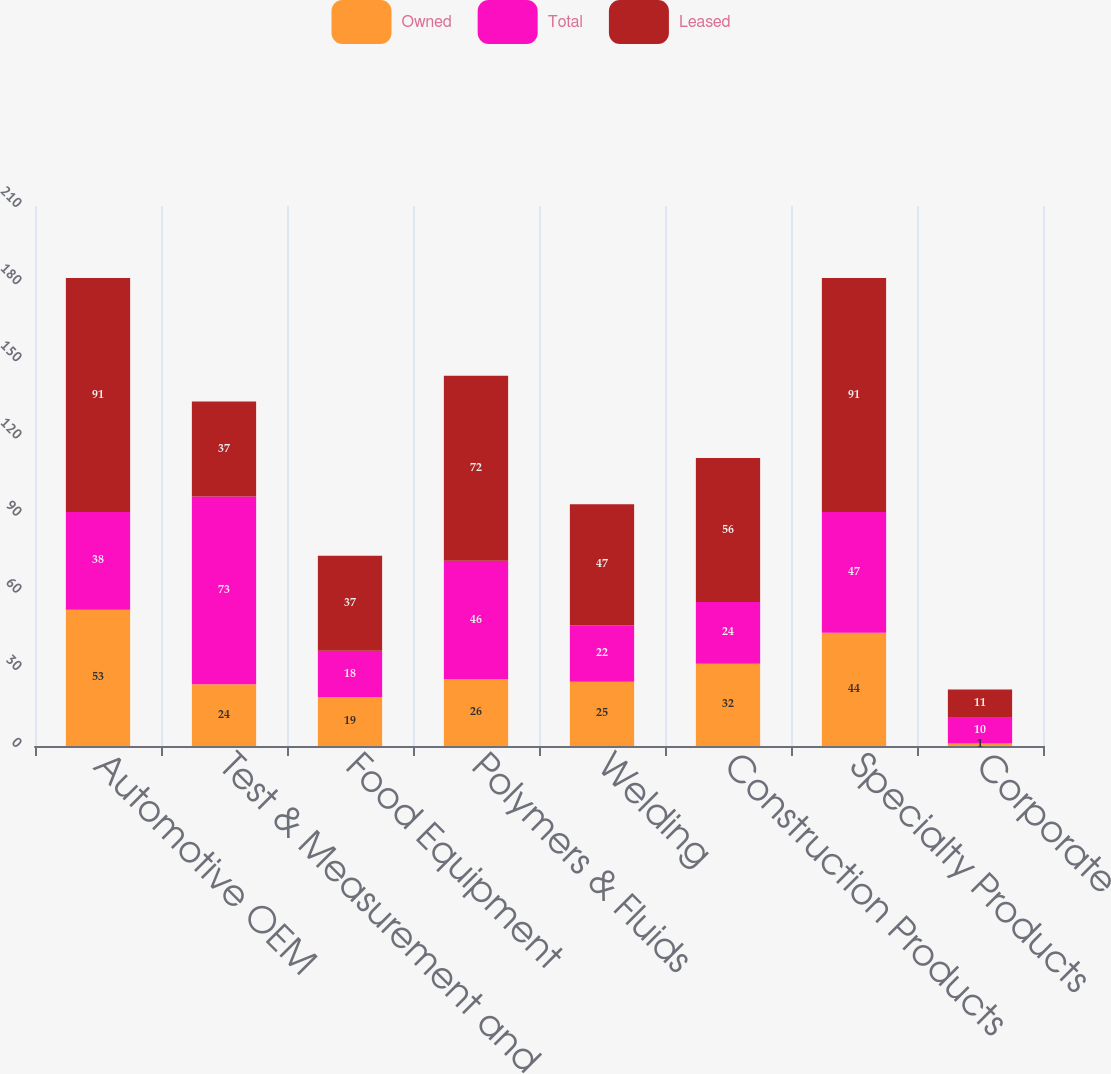Convert chart. <chart><loc_0><loc_0><loc_500><loc_500><stacked_bar_chart><ecel><fcel>Automotive OEM<fcel>Test & Measurement and<fcel>Food Equipment<fcel>Polymers & Fluids<fcel>Welding<fcel>Construction Products<fcel>Specialty Products<fcel>Corporate<nl><fcel>Owned<fcel>53<fcel>24<fcel>19<fcel>26<fcel>25<fcel>32<fcel>44<fcel>1<nl><fcel>Total<fcel>38<fcel>73<fcel>18<fcel>46<fcel>22<fcel>24<fcel>47<fcel>10<nl><fcel>Leased<fcel>91<fcel>37<fcel>37<fcel>72<fcel>47<fcel>56<fcel>91<fcel>11<nl></chart> 